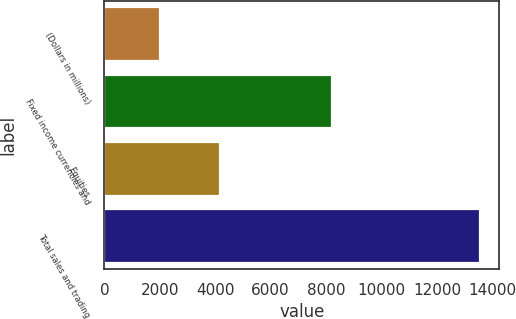Convert chart to OTSL. <chart><loc_0><loc_0><loc_500><loc_500><bar_chart><fcel>(Dollars in millions)<fcel>Fixed income currencies and<fcel>Equities<fcel>Total sales and trading<nl><fcel>2013<fcel>8231<fcel>4180<fcel>13569<nl></chart> 